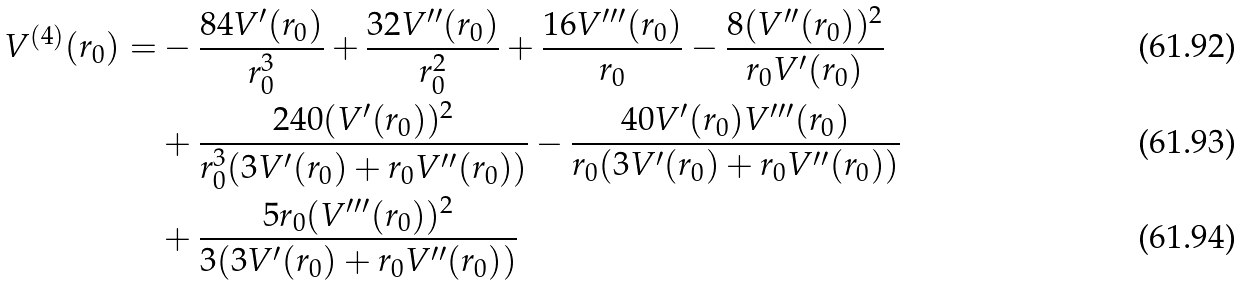<formula> <loc_0><loc_0><loc_500><loc_500>V ^ { ( 4 ) } ( r _ { 0 } ) = & - \frac { 8 4 V ^ { \prime } ( r _ { 0 } ) } { r _ { 0 } ^ { 3 } } + \frac { 3 2 V ^ { \prime \prime } ( r _ { 0 } ) } { r _ { 0 } ^ { 2 } } + \frac { 1 6 V ^ { \prime \prime \prime } ( r _ { 0 } ) } { r _ { 0 } } - \frac { 8 ( V ^ { \prime \prime } ( r _ { 0 } ) ) ^ { 2 } } { r _ { 0 } V ^ { \prime } ( r _ { 0 } ) } \\ & + \frac { 2 4 0 ( V ^ { \prime } ( r _ { 0 } ) ) ^ { 2 } } { r _ { 0 } ^ { 3 } ( 3 V ^ { \prime } ( r _ { 0 } ) + r _ { 0 } V ^ { \prime \prime } ( r _ { 0 } ) ) } - \frac { 4 0 V ^ { \prime } ( r _ { 0 } ) V ^ { \prime \prime \prime } ( r _ { 0 } ) } { r _ { 0 } ( 3 V ^ { \prime } ( r _ { 0 } ) + r _ { 0 } V ^ { \prime \prime } ( r _ { 0 } ) ) } \\ & + \frac { 5 r _ { 0 } ( V ^ { \prime \prime \prime } ( r _ { 0 } ) ) ^ { 2 } } { 3 ( 3 V ^ { \prime } ( r _ { 0 } ) + r _ { 0 } V ^ { \prime \prime } ( r _ { 0 } ) ) }</formula> 